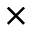<formula> <loc_0><loc_0><loc_500><loc_500>\times</formula> 